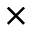<formula> <loc_0><loc_0><loc_500><loc_500>\times</formula> 